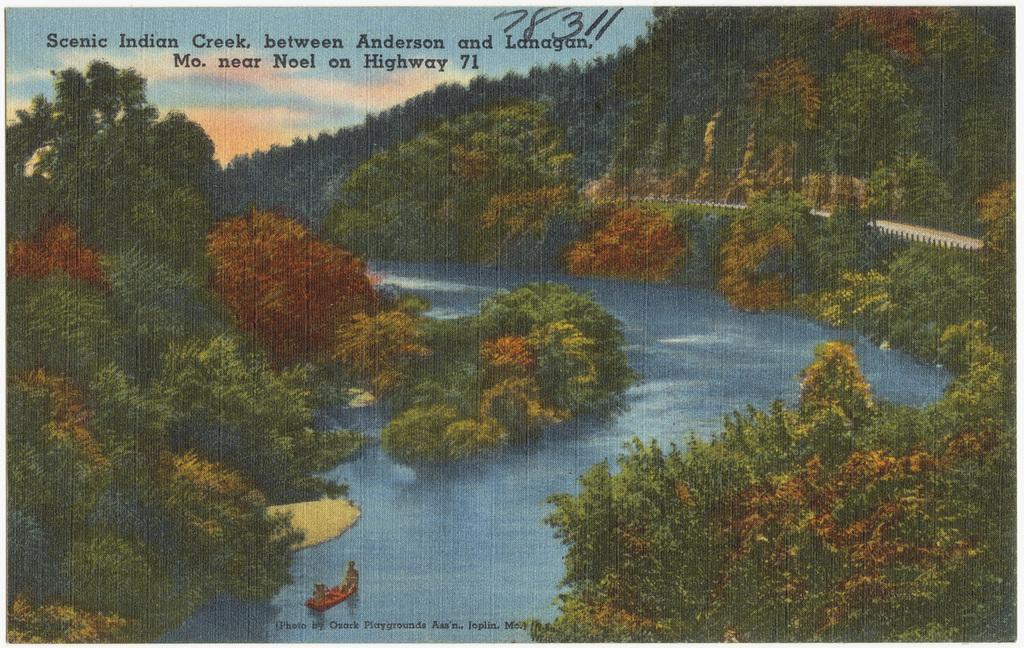Could you give a brief overview of what you see in this image? In this picture we can see the river, around there are full of trees and hills. 